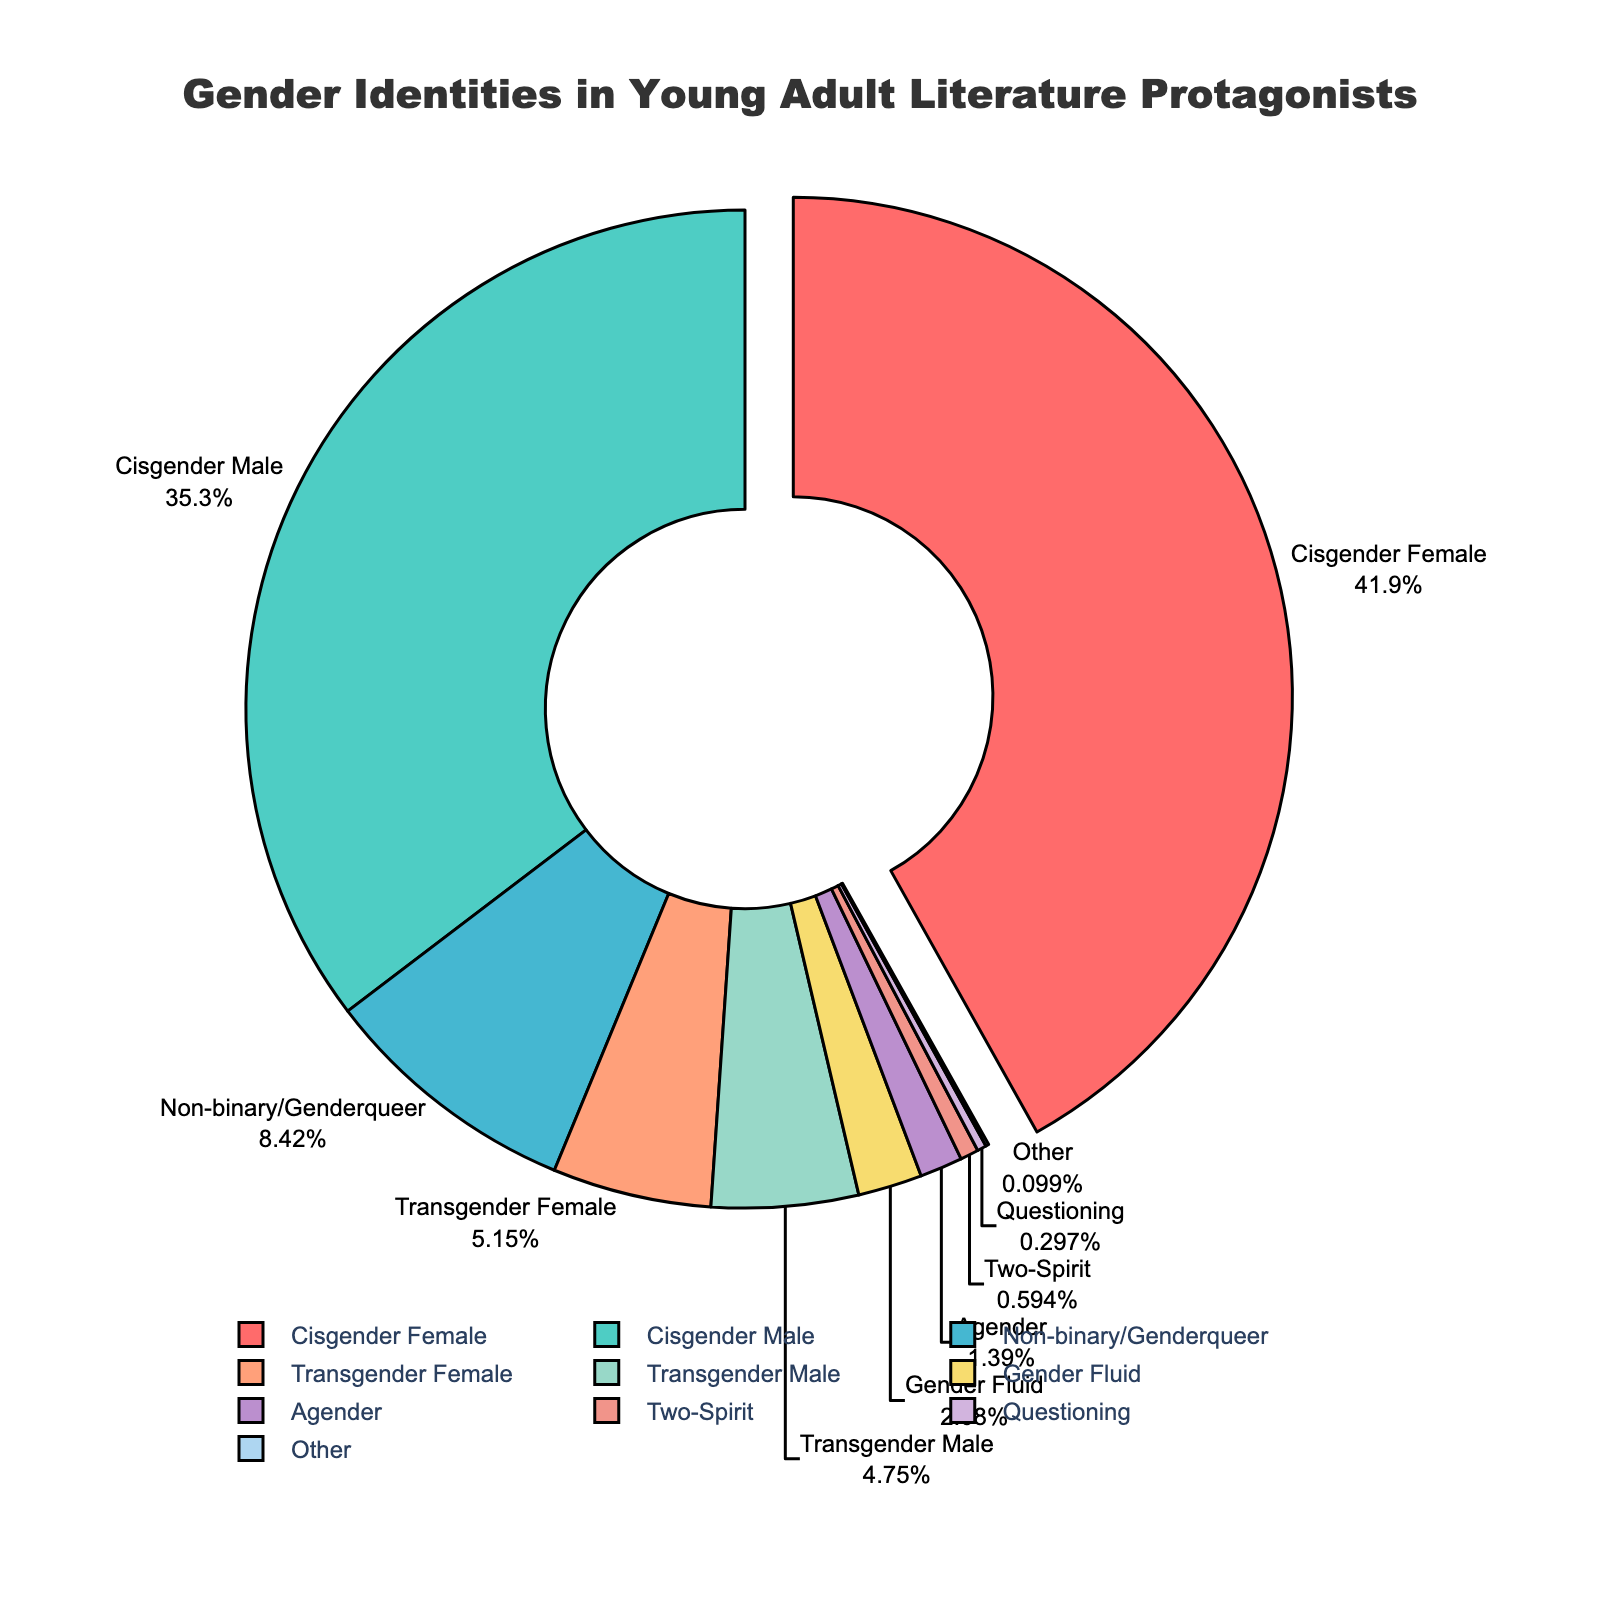What percentage of protagonists in contemporary young adult literature identify as Non-binary/Genderqueer? The figure shows a segment labeled "Non-binary/Genderqueer" with its corresponding percentage.
Answer: 8.5% Which gender identity has the highest representation among young adult literature protagonists? The figure highlights the largest segment, which is labeled "Cisgender Female."
Answer: Cisgender Female How do the percentages of Cisgender Male and Cisgender Female protagonists compare? The percentages for "Cisgender Male" and "Cisgender Female" can be seen in the figure as 35.7% and 42.3%, respectively. The former is less than the latter.
Answer: Cisgender Female > Cisgender Male What is the sum of percentages for protagonists who identify as either Transgender Female or Transgender Male? The figure shows "Transgender Female" at 5.2% and "Transgender Male" at 4.8%. Adding these together gives 5.2 + 4.8 = 10%.
Answer: 10% What is the difference in percentage between Cisgender Female and Gender Fluid protagonists? The figure shows "Cisgender Female" at 42.3% and "Gender Fluid" at 2.1%. Subtracting these gives 42.3 - 2.1 = 40.2%.
Answer: 40.2% If you sum the percentages of all non-cisgender identities, what is the total? The figure shows the percentages for non-cisgender identities: Non-binary/Genderqueer (8.5%), Transgender Female (5.2%), Transgender Male (4.8%), Gender Fluid (2.1%), Agender (1.4%), Two-Spirit (0.6%), Questioning (0.3%), and Other (0.1%). Adding these together gives 8.5 + 5.2 + 4.8 + 2.1 + 1.4 + 0.6 + 0.3 + 0.1 = 23%.
Answer: 23% Which gender identity category has the smallest representation in the dataset? The figure shows the smallest segment labeled "Other" with a percentage of 0.1%.
Answer: Other What is the combined percentage of protagonists categorized as Agender, Two-Spirit, and Questioning? The figure shows "Agender" at 1.4%, "Two-Spirit" at 0.6%, and "Questioning" at 0.3%. Adding these together gives 1.4 + 0.6 + 0.3 = 2.3%.
Answer: 2.3% Is the percentage of Non-binary/Genderqueer protagonists greater than the total percentage of all transgender protagonists? The figure shows "Non-binary/Genderqueer" at 8.5%, and the combined total for "Transgender Female" and "Transgender Male" is 10%. Thus, 8.5% is less than 10%.
Answer: No What are the main colors used to represent Transgender Female and Cisgender Male categories in the pie chart? The figure uses specific colors to represent different categories. Transgender Female is shown in a lighter shade, while Cisgender Male is in blueish-green.
Answer: Light shade for Transgender Female, blueish-green for Cisgender Male 